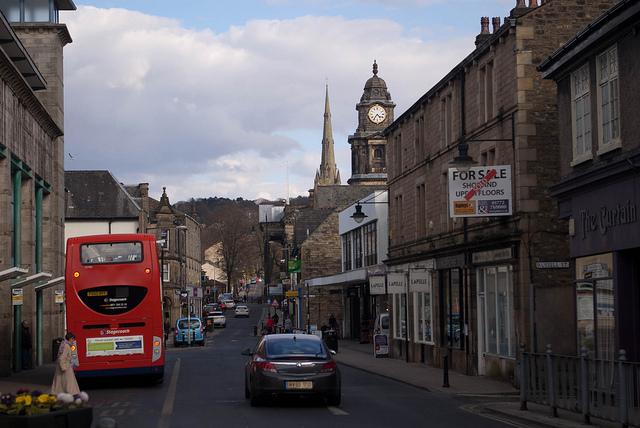What color is the bus?
Concise answer only. Red. What color is the building in the background?
Answer briefly. Brown. What kind of sign is in the middle of the road?
Concise answer only. For sale. What sign is the graffiti on?
Be succinct. For sale. What time is it?
Concise answer only. 4:35. Is there a red hand?
Give a very brief answer. No. Is the yellow sign upside down?
Concise answer only. No. Has the building on the right been sold?
Be succinct. Yes. What time does the clock say?
Answer briefly. 4:35. What establishment is on the right hand side of the street?
Keep it brief. Restaurant. How many clock faces are visible?
Keep it brief. 1. Is the sign in English?
Concise answer only. Yes. 